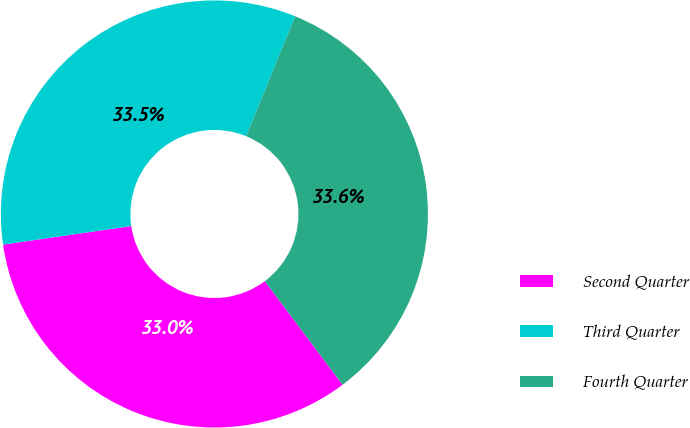<chart> <loc_0><loc_0><loc_500><loc_500><pie_chart><fcel>Second Quarter<fcel>Third Quarter<fcel>Fourth Quarter<nl><fcel>32.96%<fcel>33.47%<fcel>33.58%<nl></chart> 